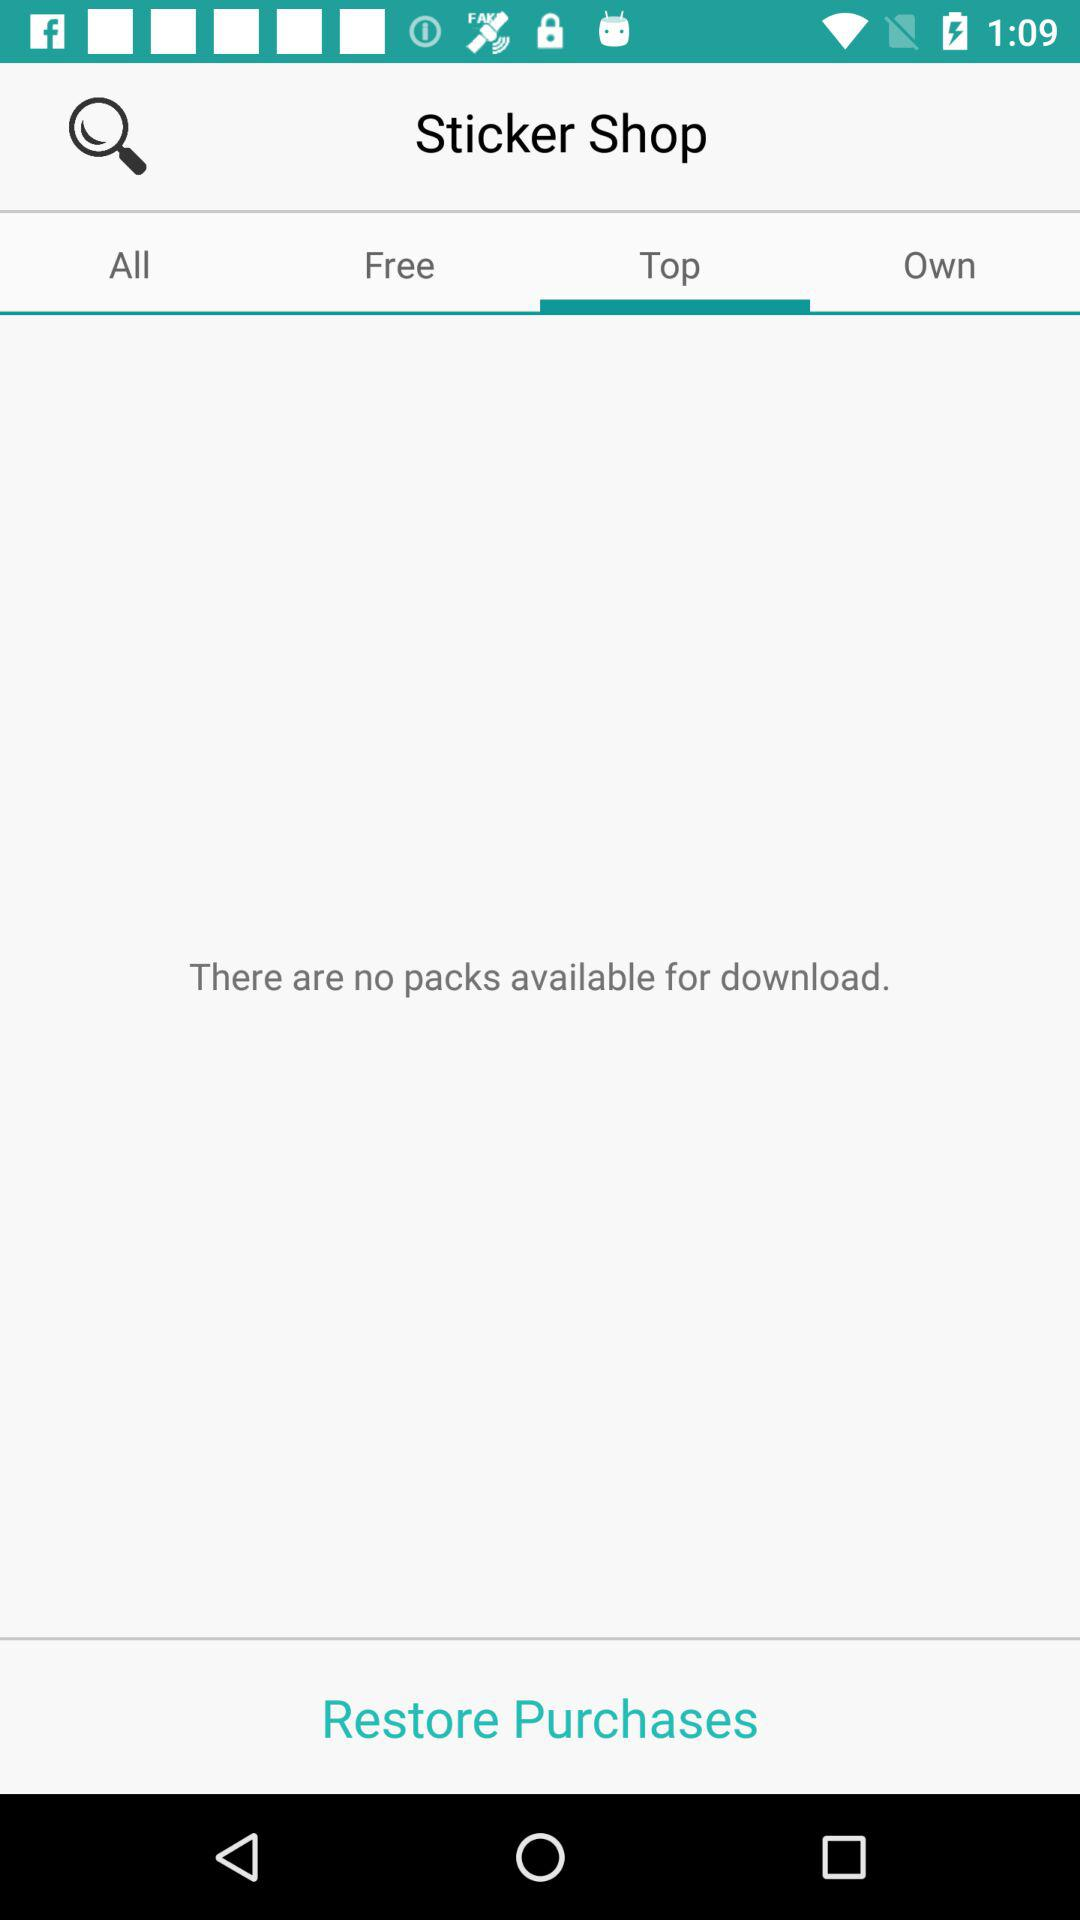How many packs are available for download?
Answer the question using a single word or phrase. 0 